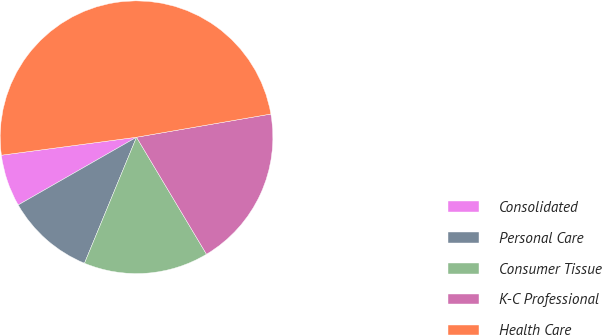Convert chart. <chart><loc_0><loc_0><loc_500><loc_500><pie_chart><fcel>Consolidated<fcel>Personal Care<fcel>Consumer Tissue<fcel>K-C Professional<fcel>Health Care<nl><fcel>6.17%<fcel>10.49%<fcel>14.81%<fcel>19.14%<fcel>49.38%<nl></chart> 